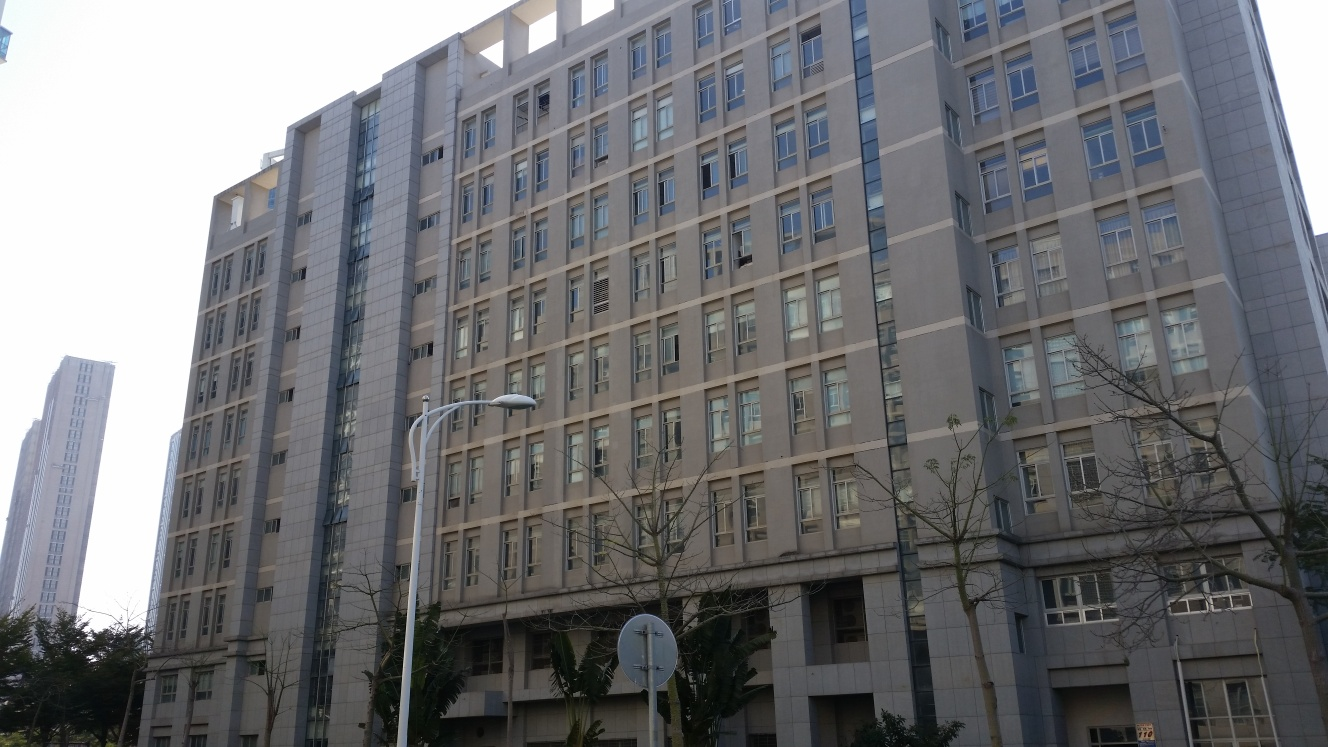Examine the image's quality and provide an evaluation based on your observations. The image displays a modern, multi-story building, featuring rows of small windows and consist uniformsand tones. The clarity and sharpness are satisfactory, capturing the textures of the building's façade adequately. Lighting appears natural and even, providing a clear view without harsh shadows or overexposure. The alignment and symmetry in the building's structure are well-maintained within the frame. Overall, the quality of the image is good, with effective capture of architectural details, though the image composition could be adjusted slightly to eliminate slight tilting visible. 